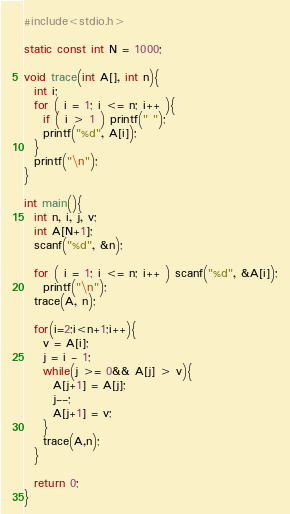<code> <loc_0><loc_0><loc_500><loc_500><_C_>#include<stdio.h>

static const int N = 1000;

void trace(int A[], int n){
  int i;
  for ( i = 1; i <= n; i++ ){
    if ( i > 1 ) printf(" ");
    printf("%d", A[i]);
  }
  printf("\n");
}

int main(){
  int n, i, j, v;
  int A[N+1];
  scanf("%d", &n);

  for ( i = 1; i <= n; i++ ) scanf("%d", &A[i]);
    printf("\n");
  trace(A, n);

  for(i=2;i<n+1;i++){
    v = A[i];
    j = i - 1;
    while(j >= 0&& A[j] > v){
      A[j+1] = A[j];
      j--;
      A[j+1] = v;
    }
    trace(A,n);
  }

  return 0;
}</code> 